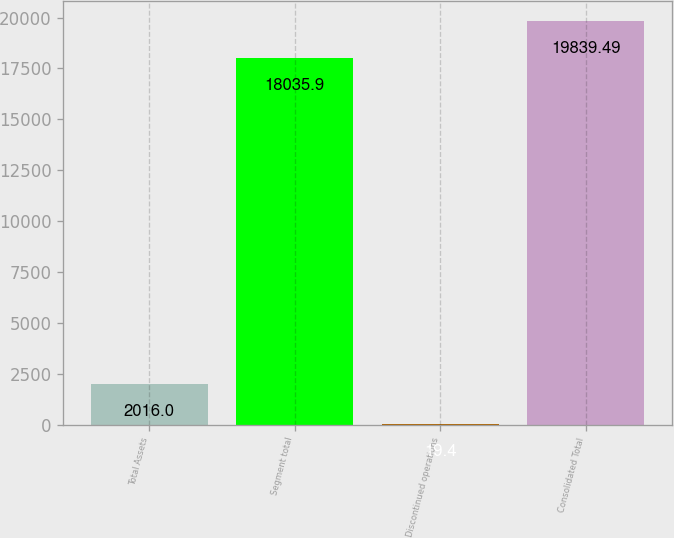Convert chart. <chart><loc_0><loc_0><loc_500><loc_500><bar_chart><fcel>Total Assets<fcel>Segment total<fcel>Discontinued operations<fcel>Consolidated Total<nl><fcel>2016<fcel>18035.9<fcel>19.4<fcel>19839.5<nl></chart> 